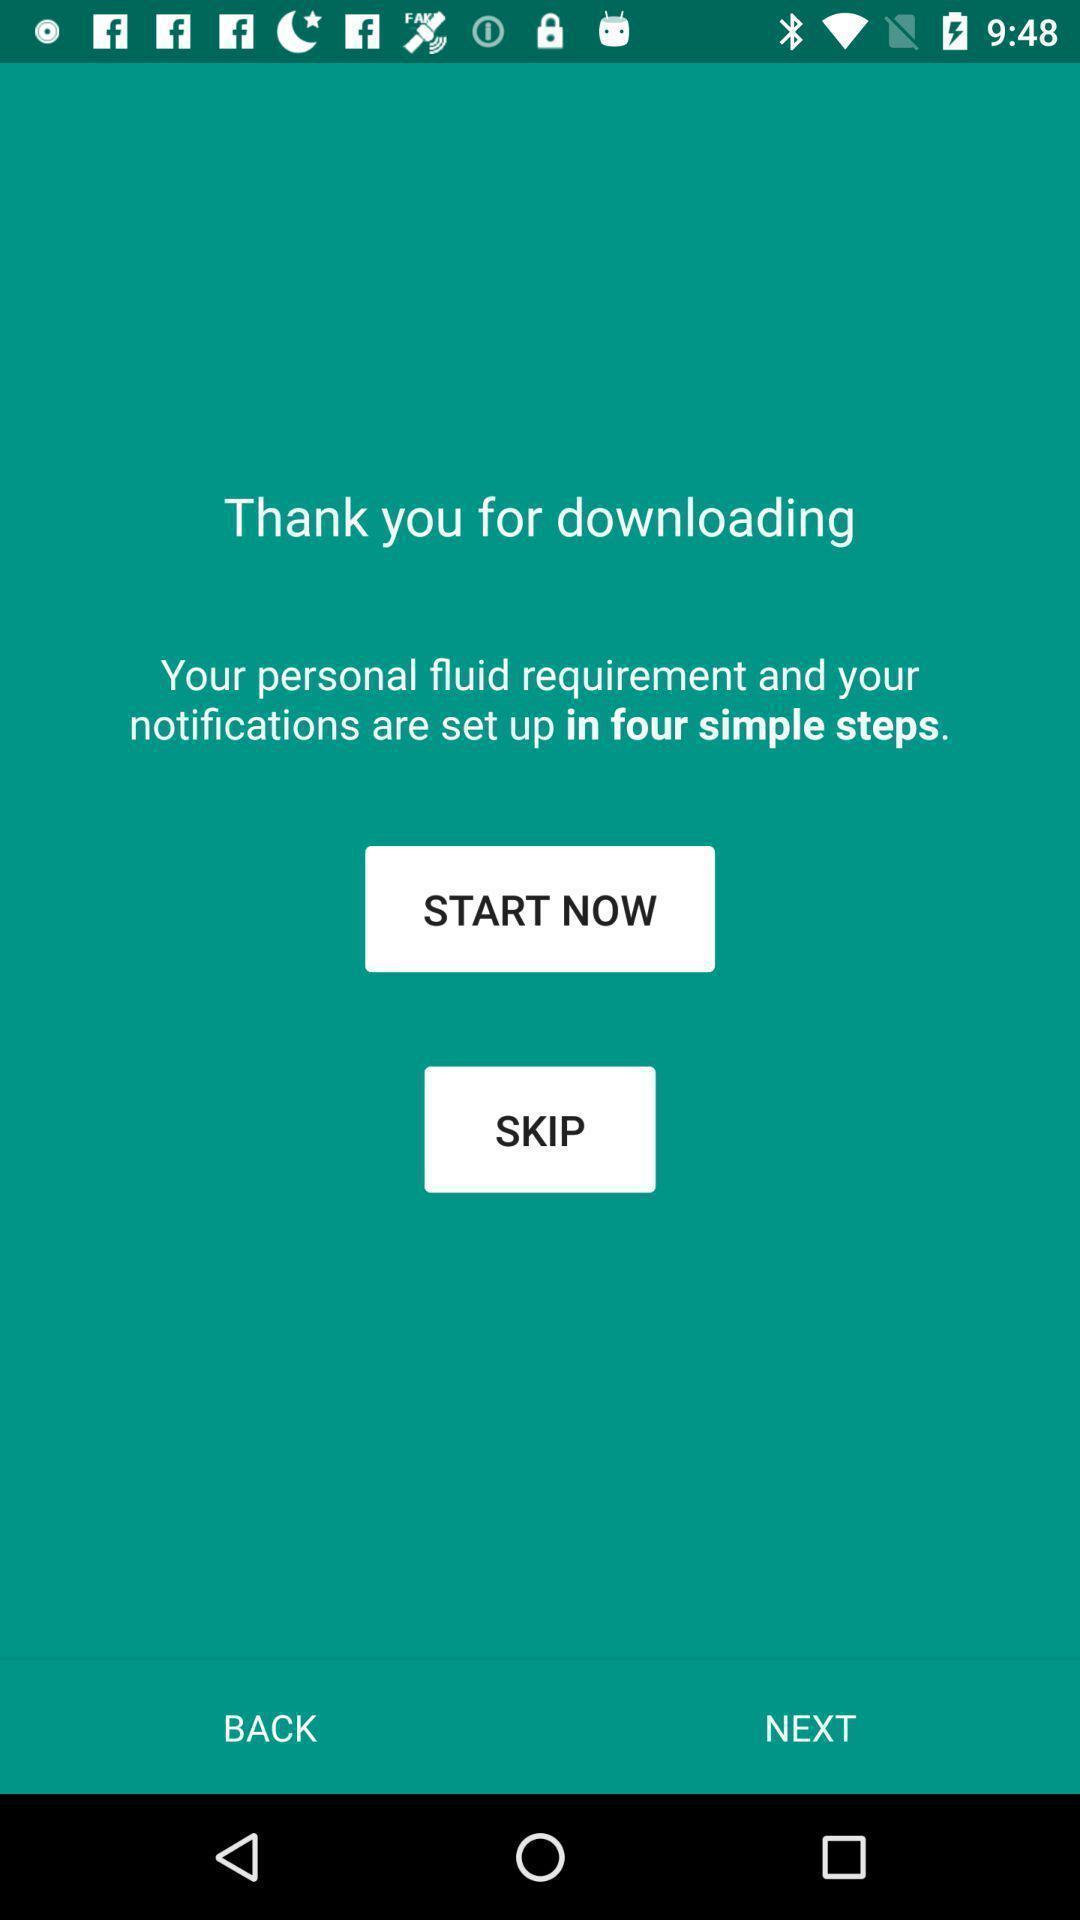What is the overall content of this screenshot? Welcome page. 